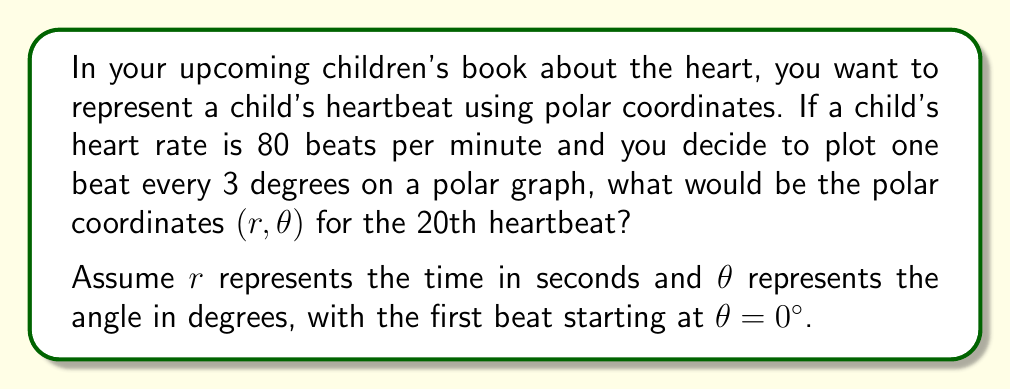Provide a solution to this math problem. Let's approach this step-by-step:

1) First, we need to calculate the time interval between heartbeats:
   $$\text{Time between beats} = \frac{60 \text{ seconds}}{80 \text{ beats}} = 0.75 \text{ seconds per beat}$$

2) Now, we can calculate the time for the 20th beat:
   $$r = 20 \text{ beats} \times 0.75 \text{ seconds/beat} = 15 \text{ seconds}$$

3) For the angle $\theta$, we know that each beat is plotted every 3 degrees:
   $$\theta = 20 \text{ beats} \times 3°/\text{beat} = 60°$$

4) Therefore, the polar coordinates for the 20th heartbeat are $(15, 60°)$.

Note: In a polar coordinate system, this would be represented as a point 15 units away from the origin, at an angle of 60° from the positive x-axis.

[asy]
import geometry;

size(200);
draw(Circle((0,0),15));
draw((0,0)--(15,0),Arrow);
draw((0,0)--(15*cos(60),15*sin(60)),Arrow);
dot((15*cos(60),15*sin(60)));
label("60°",(5,2),NE);
label("15",(7.5,0),S);
label("(15, 60°)",(15*cos(60),15*sin(60)),NE);
[/asy]
Answer: $(15, 60°)$ 